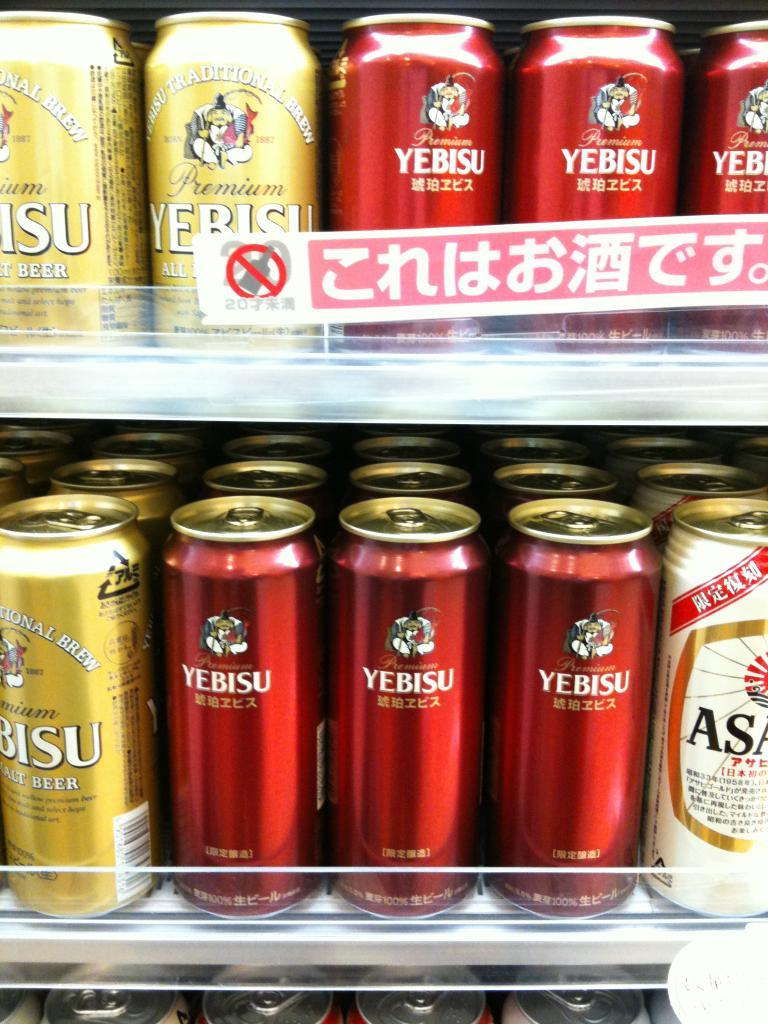<image>
Present a compact description of the photo's key features. a red can that has yebisu written on it 